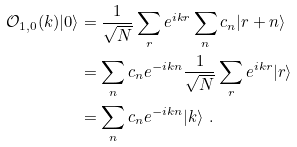Convert formula to latex. <formula><loc_0><loc_0><loc_500><loc_500>{ \mathcal { O } } _ { 1 , 0 } ( k ) | 0 \rangle & = \frac { 1 } { \sqrt { N } } \sum _ { r } e ^ { i k r } \sum _ { n } c _ { n } | r + n \rangle \\ & = \sum _ { n } c _ { n } e ^ { - i k n } \frac { 1 } { \sqrt { N } } \sum _ { r } e ^ { i k r } | r \rangle \\ & = \sum _ { n } c _ { n } e ^ { - i k n } | k \rangle \ .</formula> 